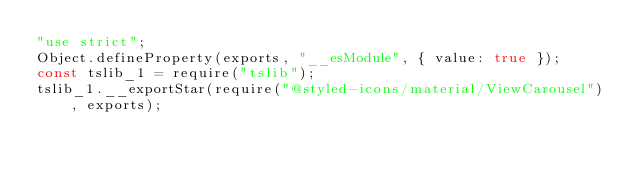Convert code to text. <code><loc_0><loc_0><loc_500><loc_500><_JavaScript_>"use strict";
Object.defineProperty(exports, "__esModule", { value: true });
const tslib_1 = require("tslib");
tslib_1.__exportStar(require("@styled-icons/material/ViewCarousel"), exports);
</code> 